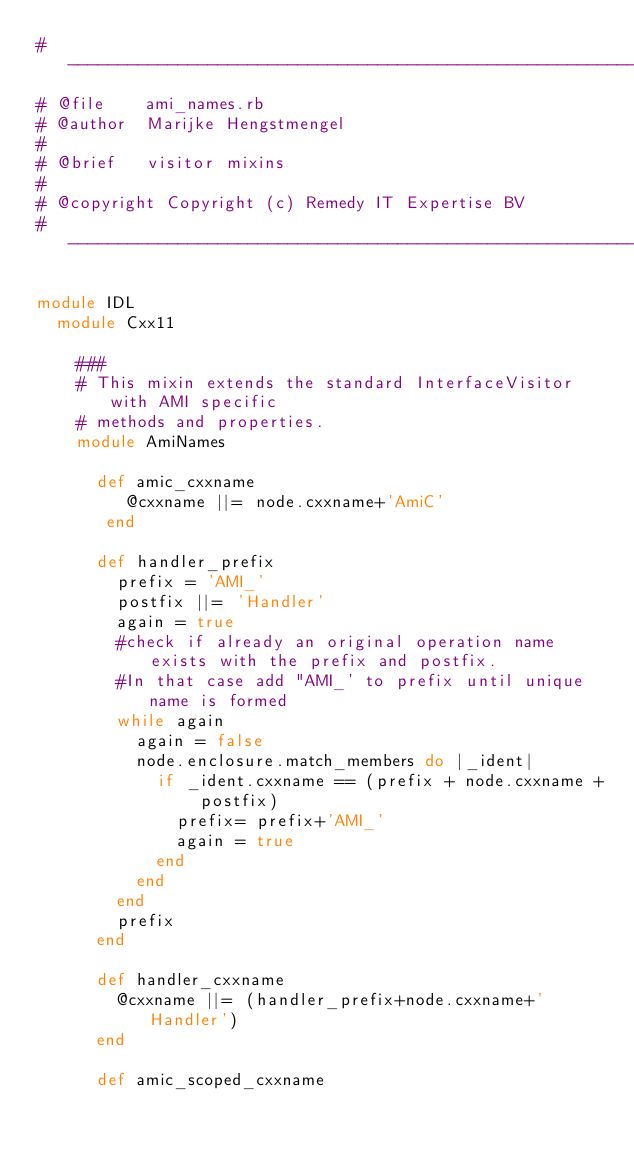<code> <loc_0><loc_0><loc_500><loc_500><_Ruby_>#--------------------------------------------------------------------
# @file    ami_names.rb
# @author  Marijke Hengstmengel
#
# @brief   visitor mixins
#
# @copyright Copyright (c) Remedy IT Expertise BV
#--------------------------------------------------------------------

module IDL
  module Cxx11

    ###
    # This mixin extends the standard InterfaceVisitor with AMI specific
    # methods and properties.
    module AmiNames

      def amic_cxxname
         @cxxname ||= node.cxxname+'AmiC'
       end

      def handler_prefix
        prefix = 'AMI_'
        postfix ||= 'Handler'
        again = true
        #check if already an original operation name exists with the prefix and postfix.
        #In that case add "AMI_' to prefix until unique name is formed
        while again
          again = false
          node.enclosure.match_members do |_ident|
            if _ident.cxxname == (prefix + node.cxxname + postfix)
              prefix= prefix+'AMI_'
              again = true
            end
          end
        end
        prefix
      end

      def handler_cxxname
        @cxxname ||= (handler_prefix+node.cxxname+'Handler')
      end

      def amic_scoped_cxxname</code> 